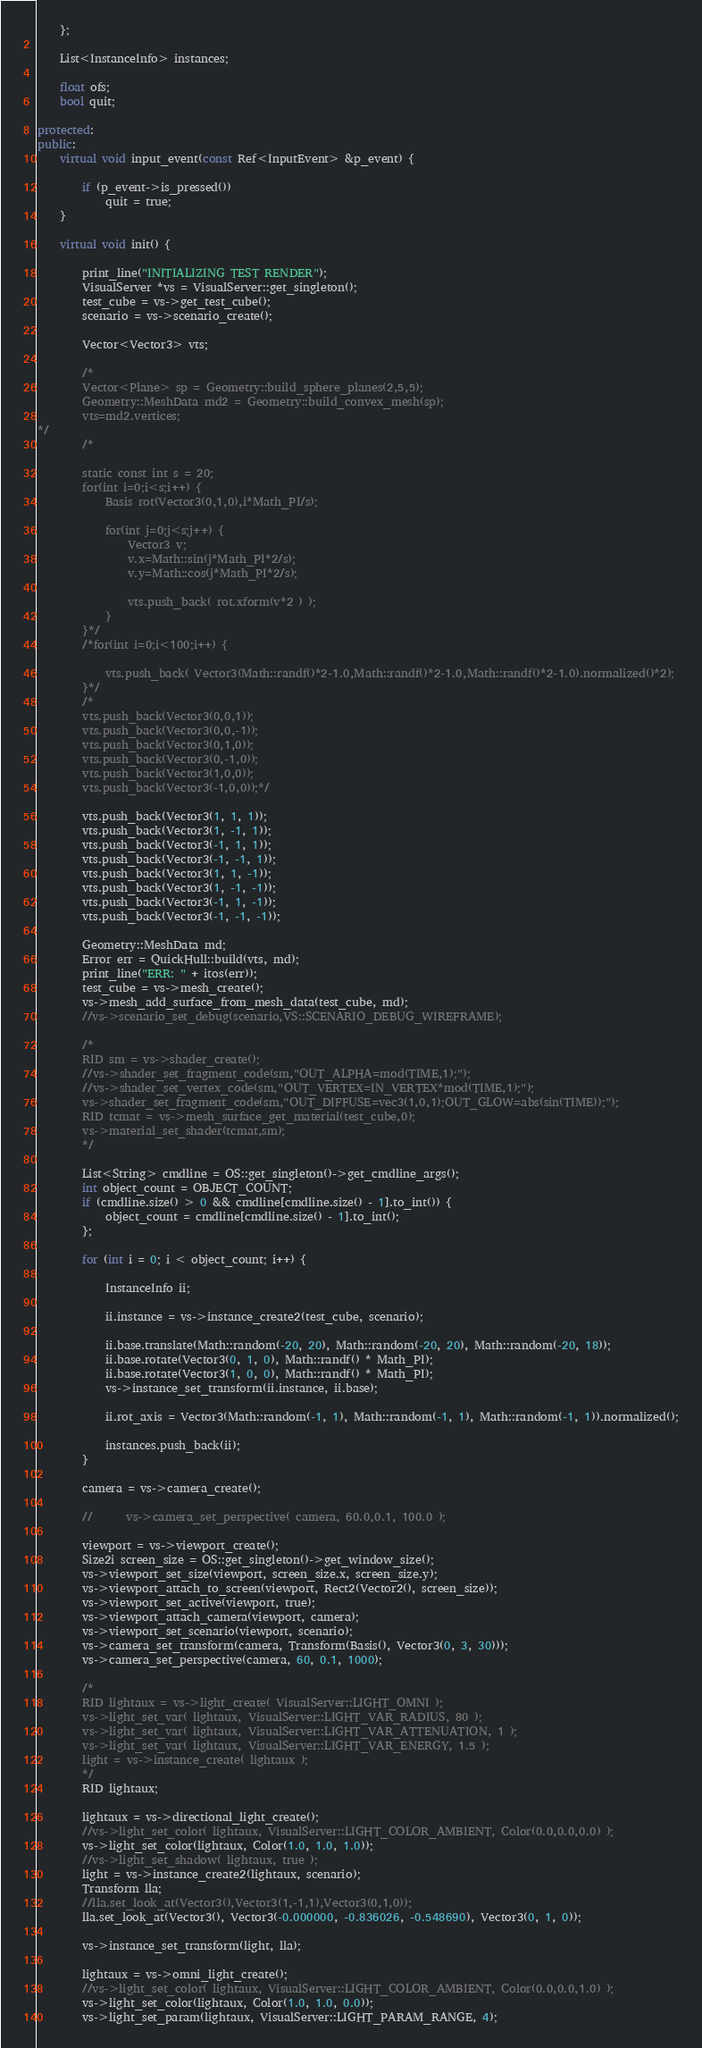Convert code to text. <code><loc_0><loc_0><loc_500><loc_500><_C++_>	};

	List<InstanceInfo> instances;

	float ofs;
	bool quit;

protected:
public:
	virtual void input_event(const Ref<InputEvent> &p_event) {

		if (p_event->is_pressed())
			quit = true;
	}

	virtual void init() {

		print_line("INITIALIZING TEST RENDER");
		VisualServer *vs = VisualServer::get_singleton();
		test_cube = vs->get_test_cube();
		scenario = vs->scenario_create();

		Vector<Vector3> vts;

		/*
		Vector<Plane> sp = Geometry::build_sphere_planes(2,5,5);
		Geometry::MeshData md2 = Geometry::build_convex_mesh(sp);
		vts=md2.vertices;
*/
		/*

		static const int s = 20;
		for(int i=0;i<s;i++) {
			Basis rot(Vector3(0,1,0),i*Math_PI/s);

			for(int j=0;j<s;j++) {
				Vector3 v;
				v.x=Math::sin(j*Math_PI*2/s);
				v.y=Math::cos(j*Math_PI*2/s);

				vts.push_back( rot.xform(v*2 ) );
			}
		}*/
		/*for(int i=0;i<100;i++) {

			vts.push_back( Vector3(Math::randf()*2-1.0,Math::randf()*2-1.0,Math::randf()*2-1.0).normalized()*2);
		}*/
		/*
		vts.push_back(Vector3(0,0,1));
		vts.push_back(Vector3(0,0,-1));
		vts.push_back(Vector3(0,1,0));
		vts.push_back(Vector3(0,-1,0));
		vts.push_back(Vector3(1,0,0));
		vts.push_back(Vector3(-1,0,0));*/

		vts.push_back(Vector3(1, 1, 1));
		vts.push_back(Vector3(1, -1, 1));
		vts.push_back(Vector3(-1, 1, 1));
		vts.push_back(Vector3(-1, -1, 1));
		vts.push_back(Vector3(1, 1, -1));
		vts.push_back(Vector3(1, -1, -1));
		vts.push_back(Vector3(-1, 1, -1));
		vts.push_back(Vector3(-1, -1, -1));

		Geometry::MeshData md;
		Error err = QuickHull::build(vts, md);
		print_line("ERR: " + itos(err));
		test_cube = vs->mesh_create();
		vs->mesh_add_surface_from_mesh_data(test_cube, md);
		//vs->scenario_set_debug(scenario,VS::SCENARIO_DEBUG_WIREFRAME);

		/*
		RID sm = vs->shader_create();
		//vs->shader_set_fragment_code(sm,"OUT_ALPHA=mod(TIME,1);");
		//vs->shader_set_vertex_code(sm,"OUT_VERTEX=IN_VERTEX*mod(TIME,1);");
		vs->shader_set_fragment_code(sm,"OUT_DIFFUSE=vec3(1,0,1);OUT_GLOW=abs(sin(TIME));");
		RID tcmat = vs->mesh_surface_get_material(test_cube,0);
		vs->material_set_shader(tcmat,sm);
		*/

		List<String> cmdline = OS::get_singleton()->get_cmdline_args();
		int object_count = OBJECT_COUNT;
		if (cmdline.size() > 0 && cmdline[cmdline.size() - 1].to_int()) {
			object_count = cmdline[cmdline.size() - 1].to_int();
		};

		for (int i = 0; i < object_count; i++) {

			InstanceInfo ii;

			ii.instance = vs->instance_create2(test_cube, scenario);

			ii.base.translate(Math::random(-20, 20), Math::random(-20, 20), Math::random(-20, 18));
			ii.base.rotate(Vector3(0, 1, 0), Math::randf() * Math_PI);
			ii.base.rotate(Vector3(1, 0, 0), Math::randf() * Math_PI);
			vs->instance_set_transform(ii.instance, ii.base);

			ii.rot_axis = Vector3(Math::random(-1, 1), Math::random(-1, 1), Math::random(-1, 1)).normalized();

			instances.push_back(ii);
		}

		camera = vs->camera_create();

		// 		vs->camera_set_perspective( camera, 60.0,0.1, 100.0 );

		viewport = vs->viewport_create();
		Size2i screen_size = OS::get_singleton()->get_window_size();
		vs->viewport_set_size(viewport, screen_size.x, screen_size.y);
		vs->viewport_attach_to_screen(viewport, Rect2(Vector2(), screen_size));
		vs->viewport_set_active(viewport, true);
		vs->viewport_attach_camera(viewport, camera);
		vs->viewport_set_scenario(viewport, scenario);
		vs->camera_set_transform(camera, Transform(Basis(), Vector3(0, 3, 30)));
		vs->camera_set_perspective(camera, 60, 0.1, 1000);

		/*
		RID lightaux = vs->light_create( VisualServer::LIGHT_OMNI );
		vs->light_set_var( lightaux, VisualServer::LIGHT_VAR_RADIUS, 80 );
		vs->light_set_var( lightaux, VisualServer::LIGHT_VAR_ATTENUATION, 1 );
		vs->light_set_var( lightaux, VisualServer::LIGHT_VAR_ENERGY, 1.5 );
		light = vs->instance_create( lightaux );
		*/
		RID lightaux;

		lightaux = vs->directional_light_create();
		//vs->light_set_color( lightaux, VisualServer::LIGHT_COLOR_AMBIENT, Color(0.0,0.0,0.0) );
		vs->light_set_color(lightaux, Color(1.0, 1.0, 1.0));
		//vs->light_set_shadow( lightaux, true );
		light = vs->instance_create2(lightaux, scenario);
		Transform lla;
		//lla.set_look_at(Vector3(),Vector3(1,-1,1),Vector3(0,1,0));
		lla.set_look_at(Vector3(), Vector3(-0.000000, -0.836026, -0.548690), Vector3(0, 1, 0));

		vs->instance_set_transform(light, lla);

		lightaux = vs->omni_light_create();
		//vs->light_set_color( lightaux, VisualServer::LIGHT_COLOR_AMBIENT, Color(0.0,0.0,1.0) );
		vs->light_set_color(lightaux, Color(1.0, 1.0, 0.0));
		vs->light_set_param(lightaux, VisualServer::LIGHT_PARAM_RANGE, 4);</code> 